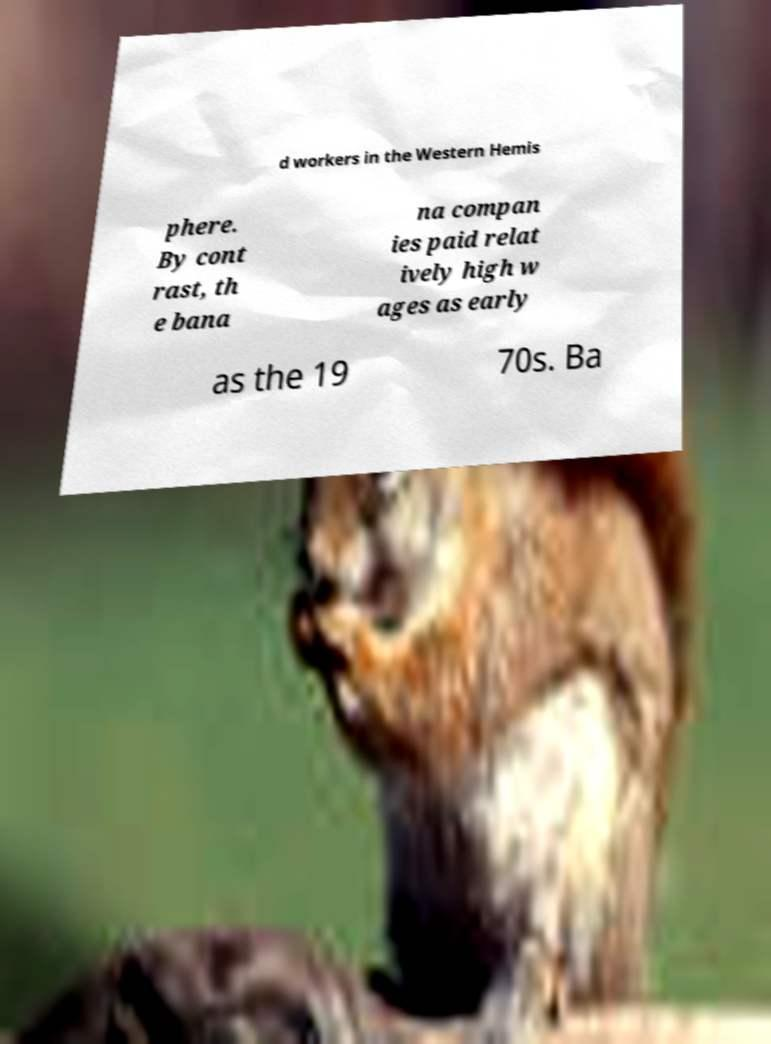For documentation purposes, I need the text within this image transcribed. Could you provide that? d workers in the Western Hemis phere. By cont rast, th e bana na compan ies paid relat ively high w ages as early as the 19 70s. Ba 